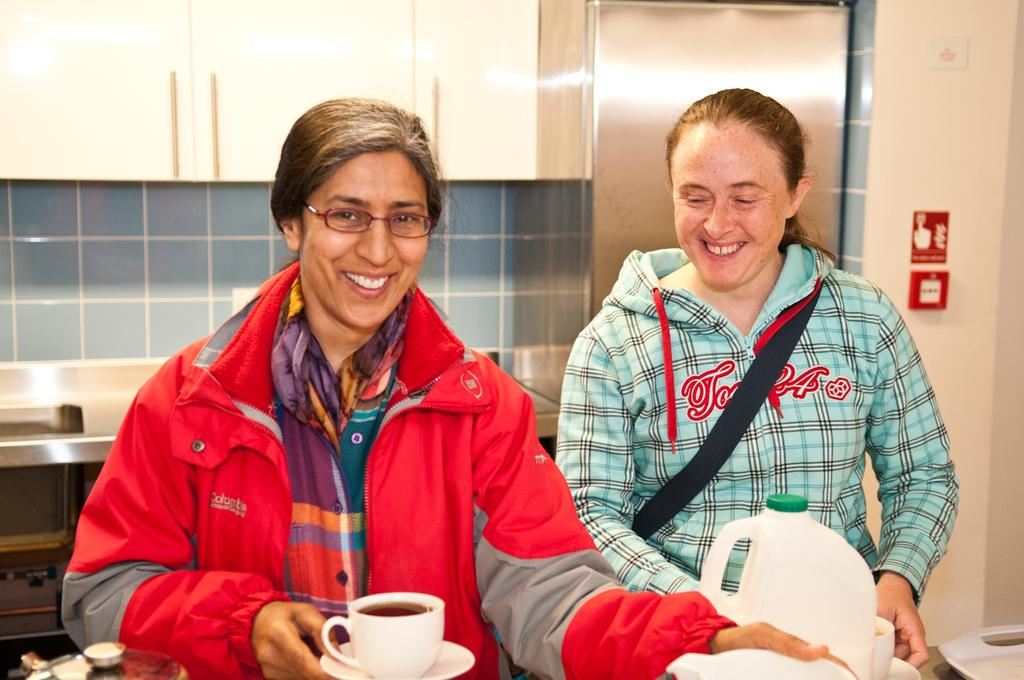How many ladies are in the image? There are two ladies in the image. What colors are the jackets worn by the ladies? One lady is wearing a red jacket, and the other lady is wearing a blue jacket. What are the ladies holding in the image? Both ladies are holding a cup. What can be seen in the background of the image? There is a shelf visible in the background of the image. What hobbies do the ladies have, as indicated by their facial expressions in the image? There is no information about the ladies' hobbies or facial expressions in the image. Can you tell me what time it is by looking at the watch on the ladies' wrists in the image? There is no watch visible on the ladies' wrists in the image. 